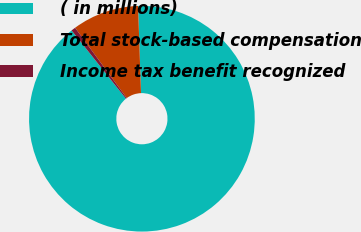<chart> <loc_0><loc_0><loc_500><loc_500><pie_chart><fcel>( in millions)<fcel>Total stock-based compensation<fcel>Income tax benefit recognized<nl><fcel>89.83%<fcel>9.54%<fcel>0.62%<nl></chart> 